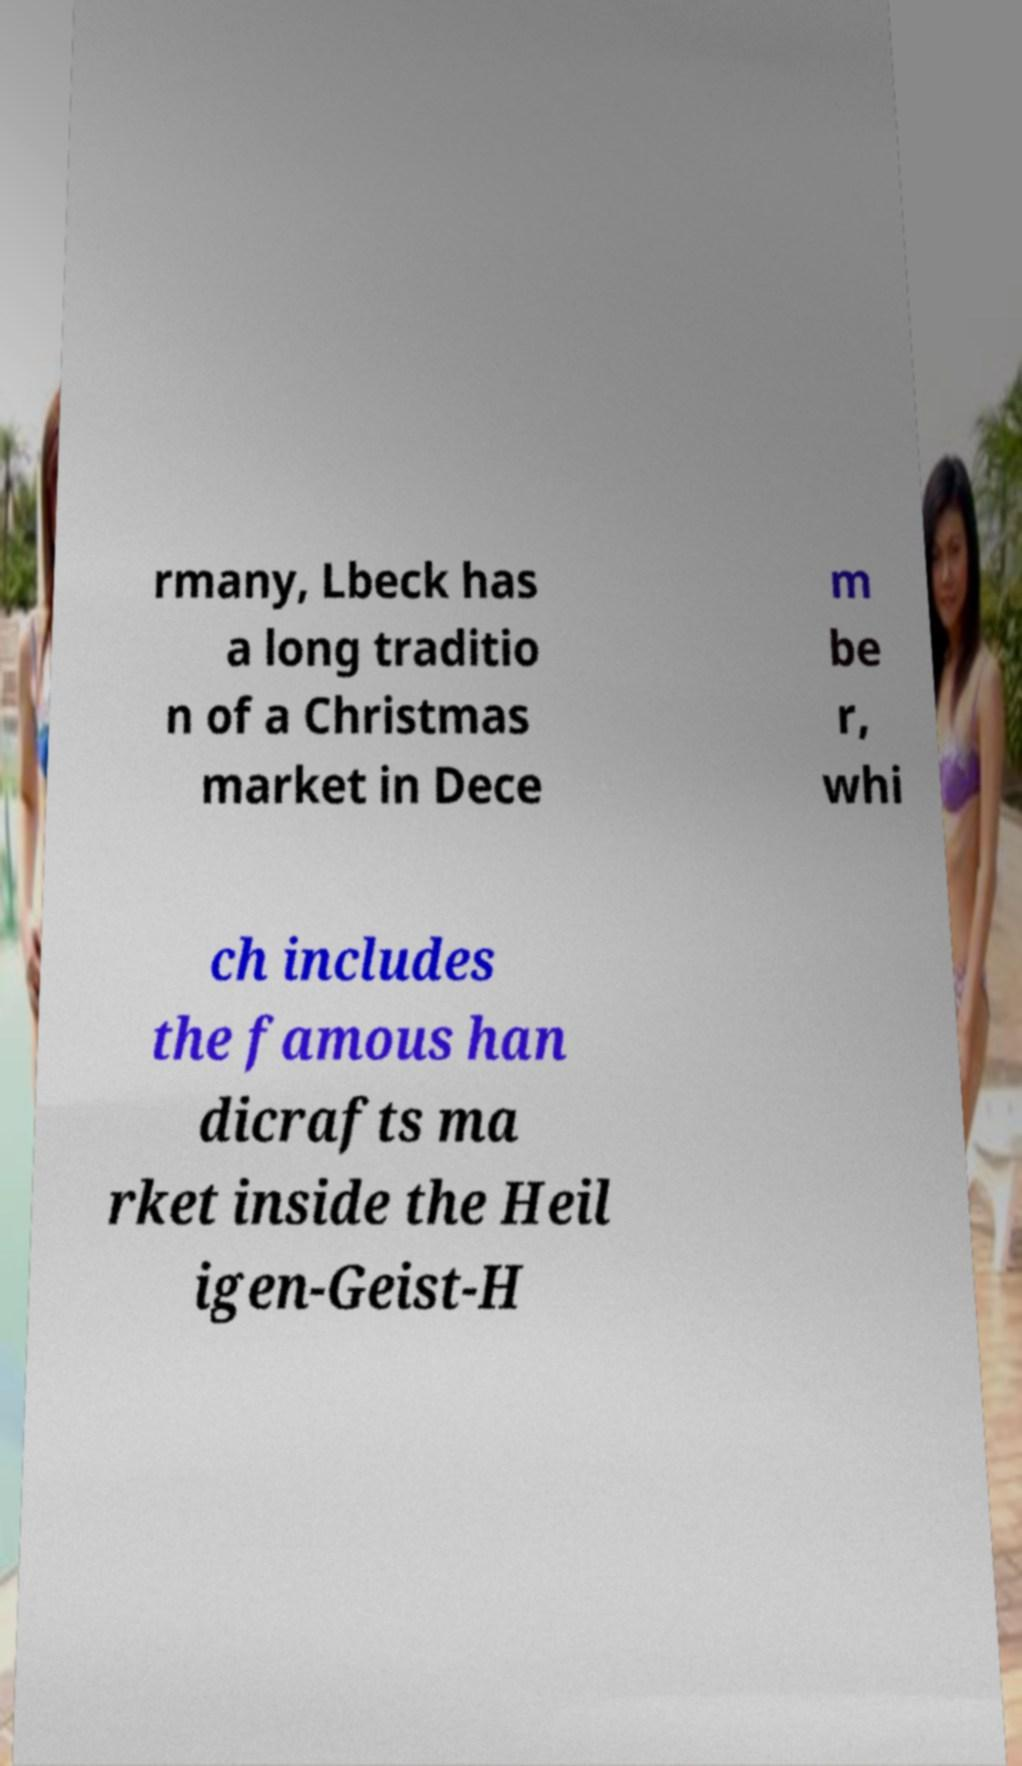There's text embedded in this image that I need extracted. Can you transcribe it verbatim? rmany, Lbeck has a long traditio n of a Christmas market in Dece m be r, whi ch includes the famous han dicrafts ma rket inside the Heil igen-Geist-H 